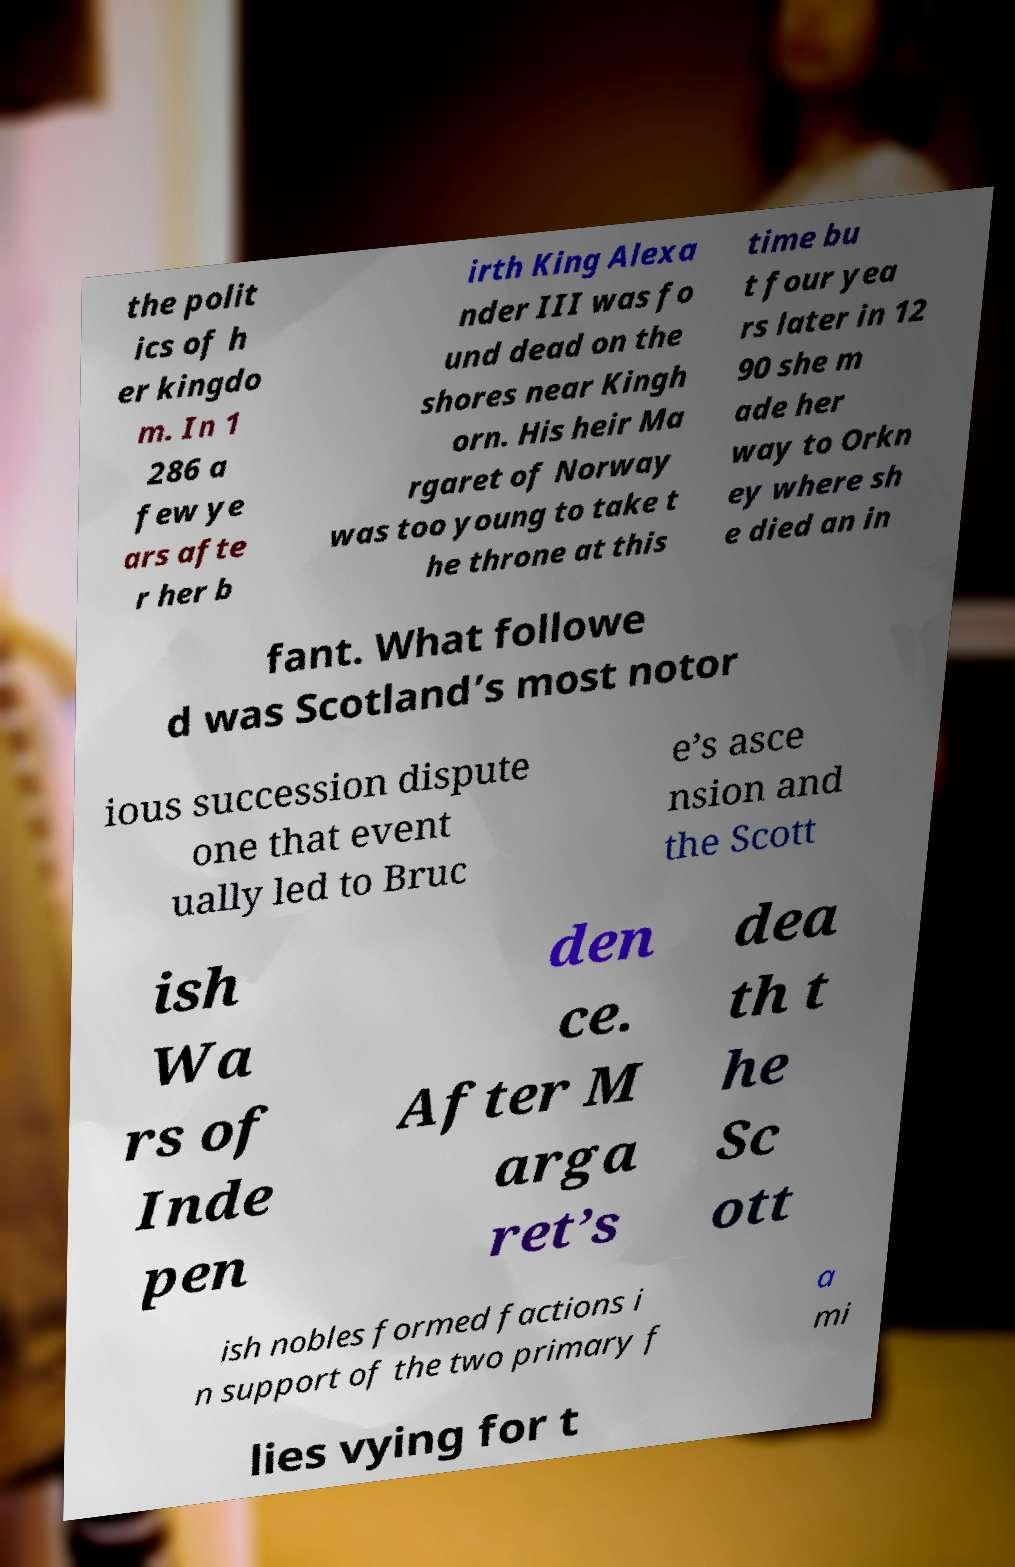Please identify and transcribe the text found in this image. the polit ics of h er kingdo m. In 1 286 a few ye ars afte r her b irth King Alexa nder III was fo und dead on the shores near Kingh orn. His heir Ma rgaret of Norway was too young to take t he throne at this time bu t four yea rs later in 12 90 she m ade her way to Orkn ey where sh e died an in fant. What followe d was Scotland’s most notor ious succession dispute one that event ually led to Bruc e’s asce nsion and the Scott ish Wa rs of Inde pen den ce. After M arga ret’s dea th t he Sc ott ish nobles formed factions i n support of the two primary f a mi lies vying for t 